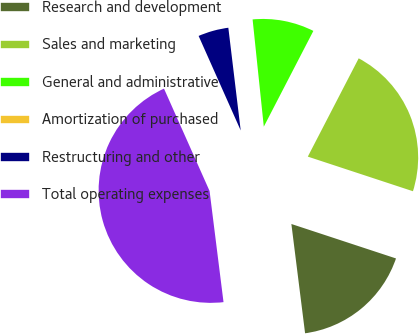Convert chart. <chart><loc_0><loc_0><loc_500><loc_500><pie_chart><fcel>Research and development<fcel>Sales and marketing<fcel>General and administrative<fcel>Amortization of purchased<fcel>Restructuring and other<fcel>Total operating expenses<nl><fcel>17.95%<fcel>22.46%<fcel>9.26%<fcel>0.25%<fcel>4.76%<fcel>45.32%<nl></chart> 